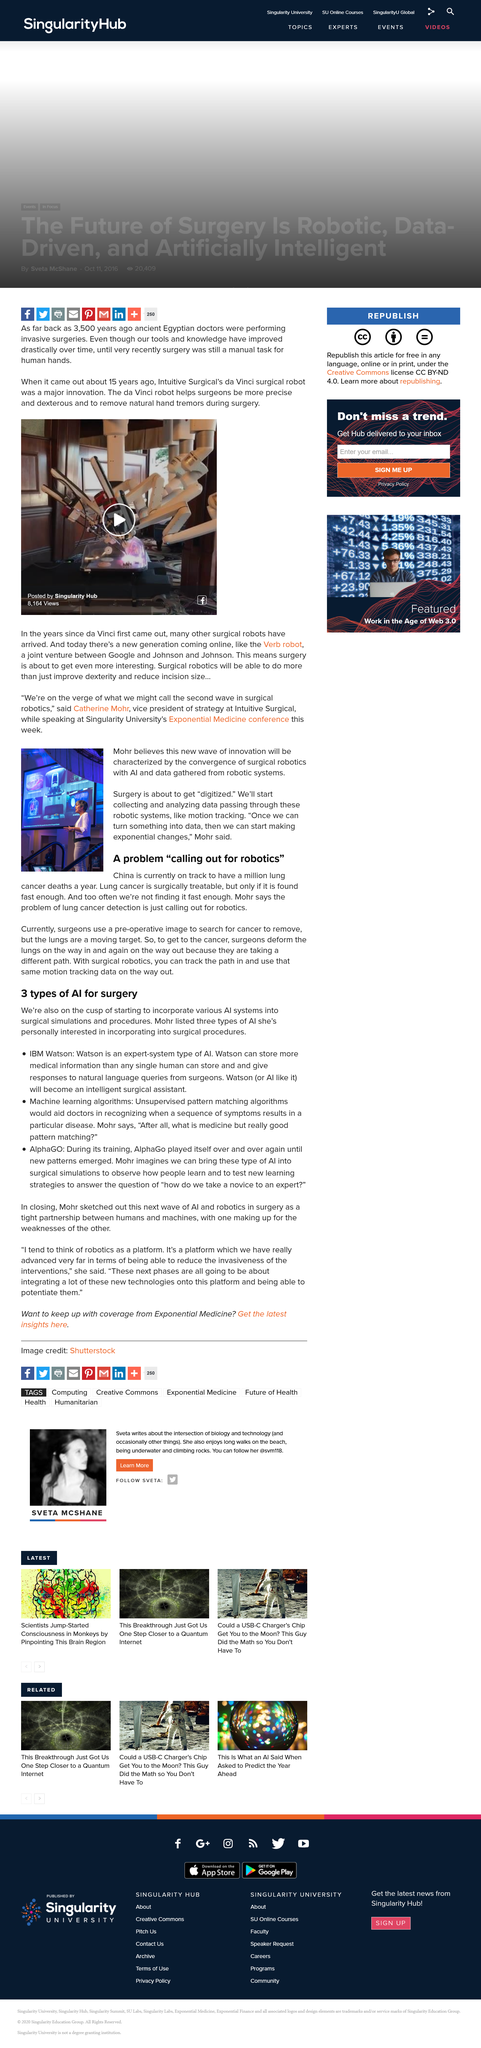Indicate a few pertinent items in this graphic. The surgery is about to undergo the process of digitization. Watson is an expert system type of AI. Watson is an expert-system type of AI. Watson is an expert system type of AI. The problem of lung cancer detection, as stated by Mohr, is in dire need of robotic intervention. 